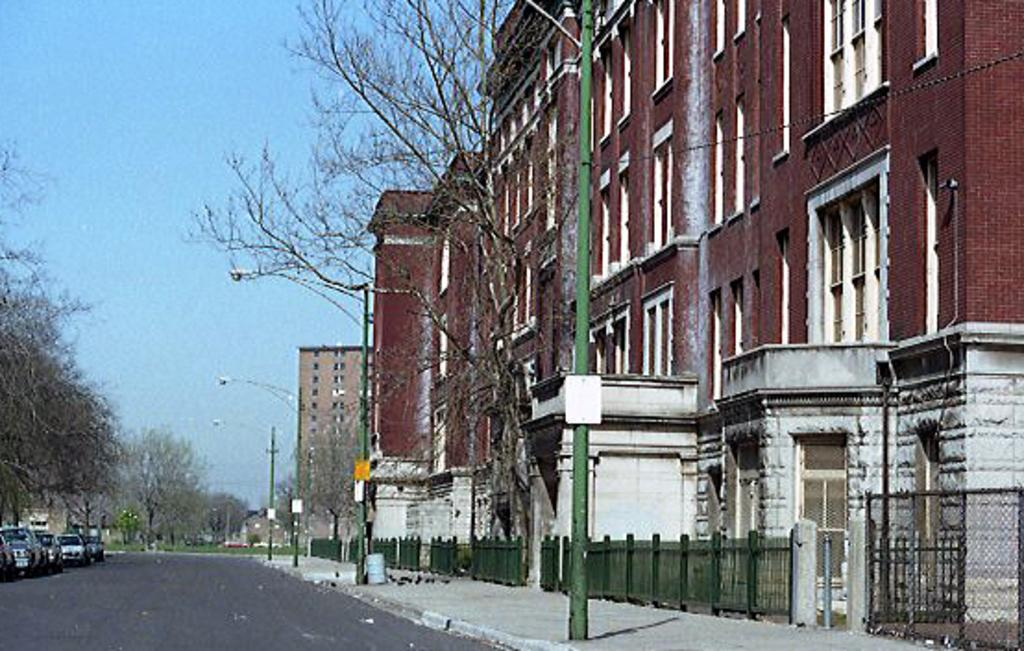What is in the foreground of the image? In the foreground of the image, there is a road, trees, poles, railing, fencing, and buildings. What is happening on the road? There are vehicles on the road. What can be seen in the sky? The sky is visible at the top of the image. Who is the expert on the road in the image? There is no expert present on the road in the image. What reward can be seen in the image? There is no reward visible in the image. 